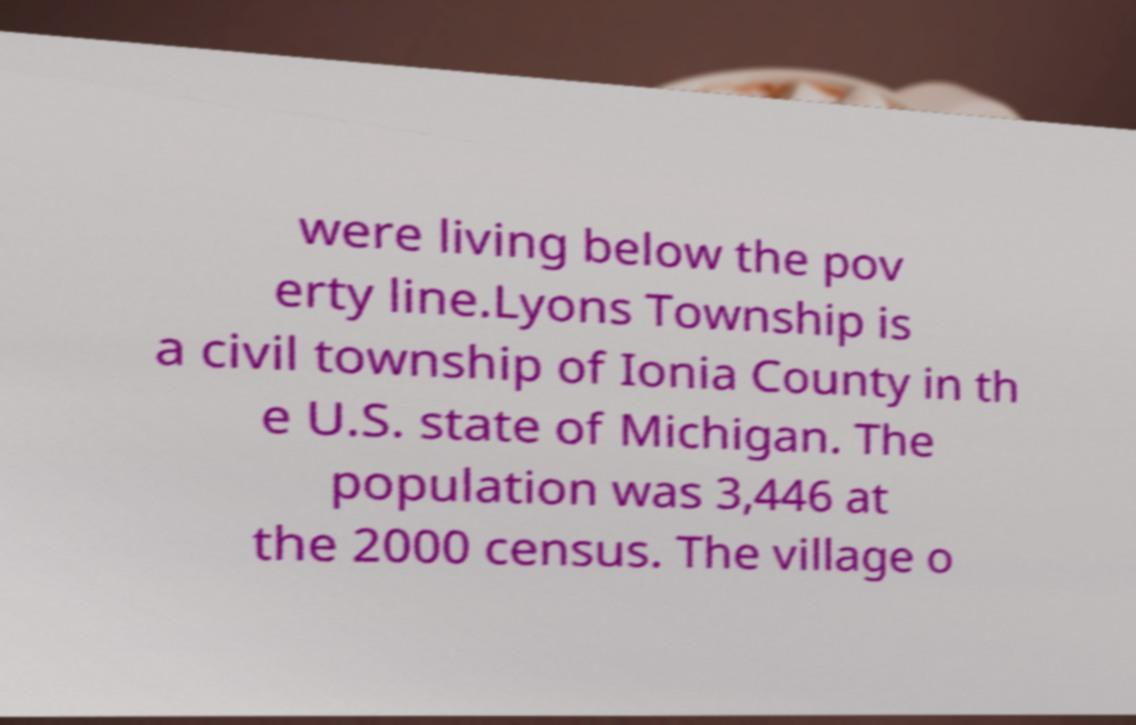Could you assist in decoding the text presented in this image and type it out clearly? were living below the pov erty line.Lyons Township is a civil township of Ionia County in th e U.S. state of Michigan. The population was 3,446 at the 2000 census. The village o 